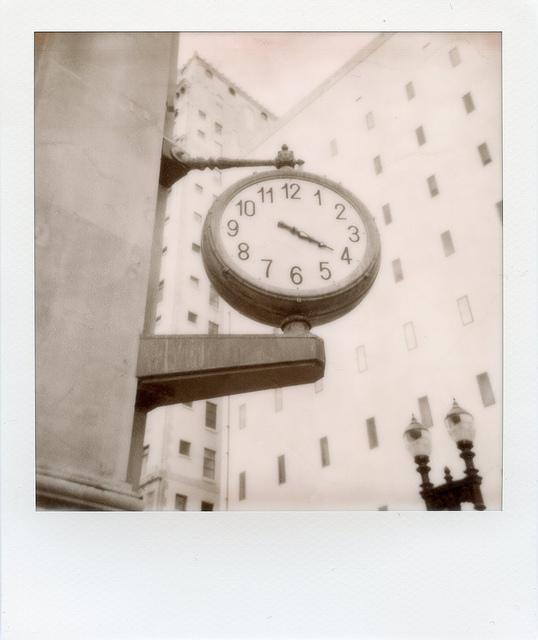How many lights are in the bottom right?
Give a very brief answer. 2. 